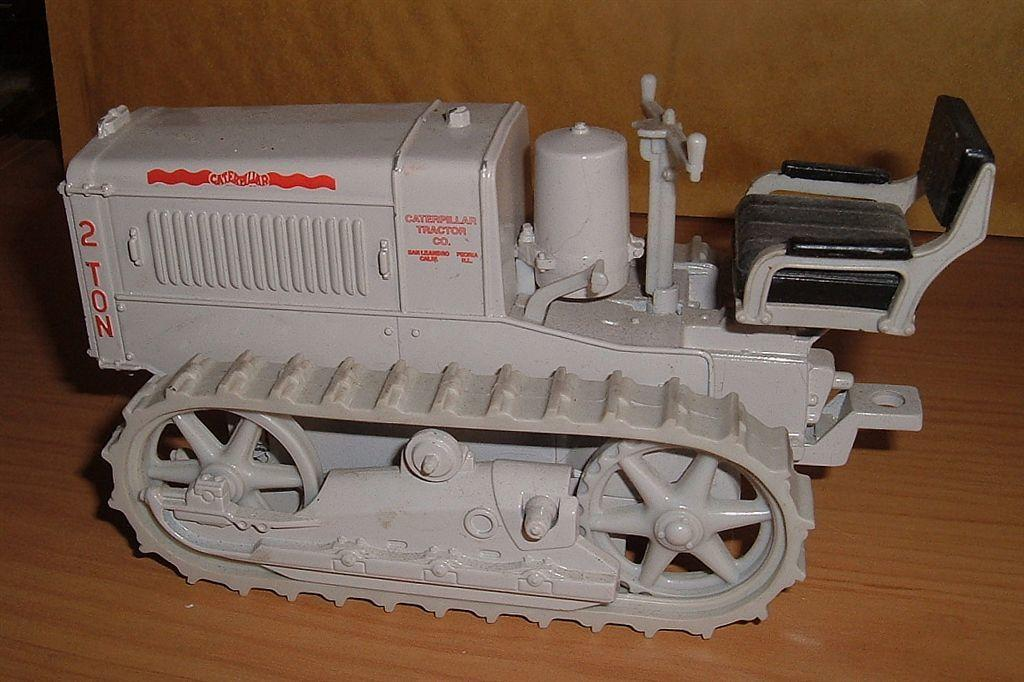What is the main subject of the image? The main subject of the image is a toy vehicle. Where is the toy vehicle located? The toy vehicle is on a wooden platform. What type of fact can be seen in the image? There is no fact present in the image; it features a toy vehicle on a wooden platform. How many cows are visible in the image? There are no cows present in the image. 